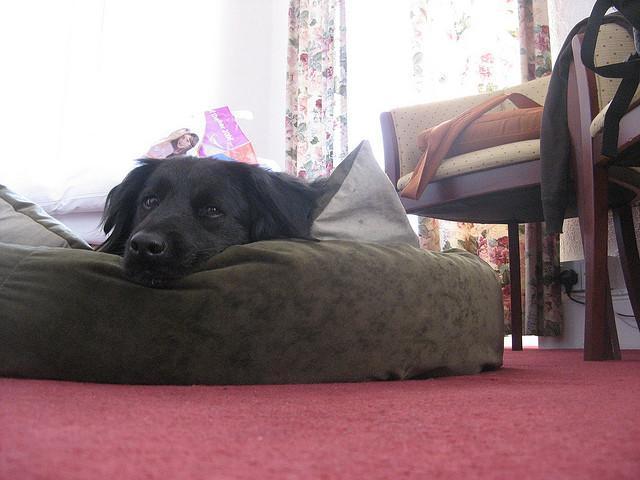How many sheep are facing the camera?
Give a very brief answer. 0. 